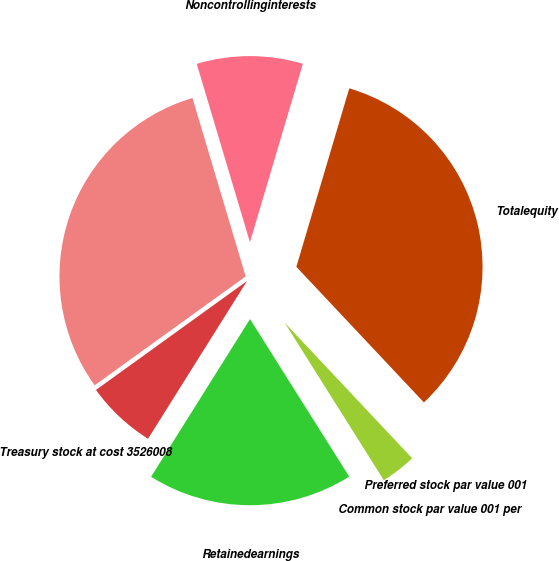Convert chart. <chart><loc_0><loc_0><loc_500><loc_500><pie_chart><fcel>Preferred stock par value 001<fcel>Common stock par value 001 per<fcel>Retainedearnings<fcel>Treasury stock at cost 3526008<fcel>Unnamed: 4<fcel>Noncontrollinginterests<fcel>Totalequity<nl><fcel>0.0%<fcel>3.07%<fcel>17.86%<fcel>6.14%<fcel>30.33%<fcel>9.2%<fcel>33.4%<nl></chart> 